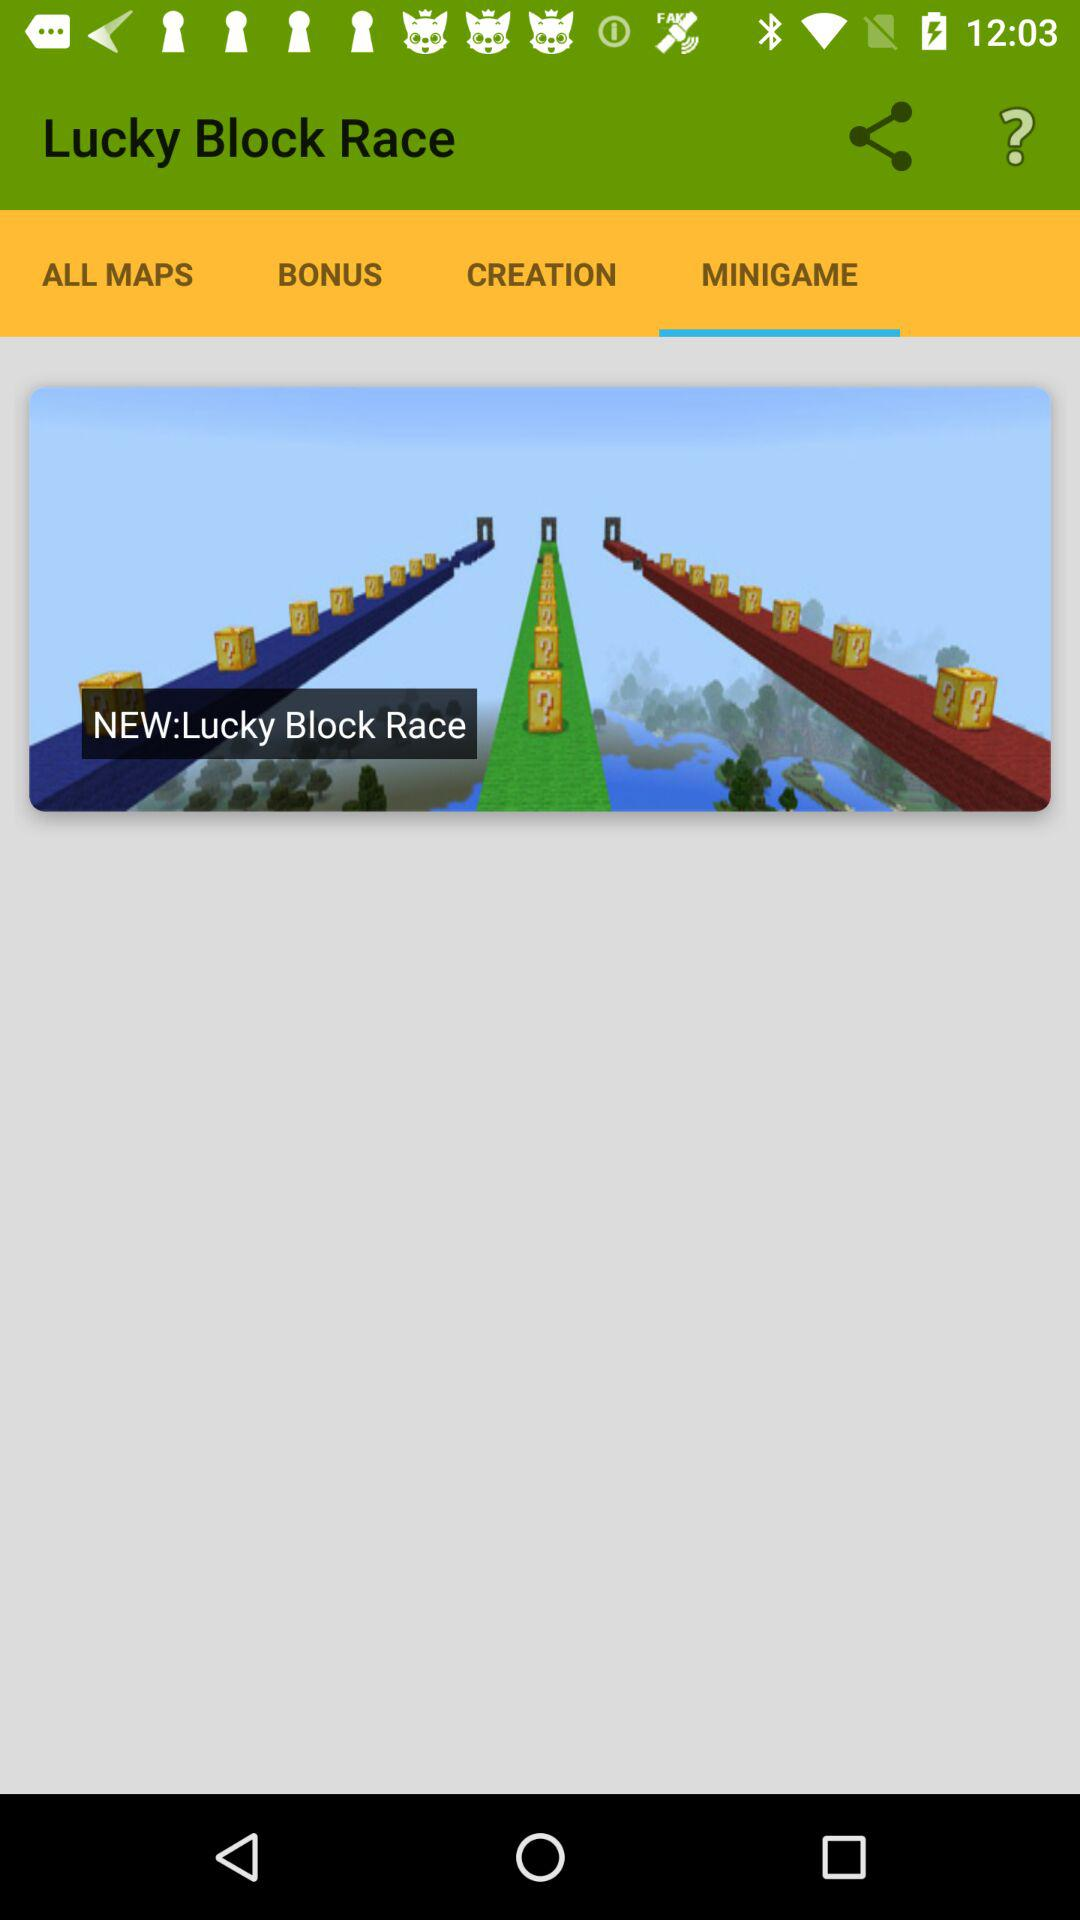What is the name of the game? The name of the game is "Lucky Block Race". 